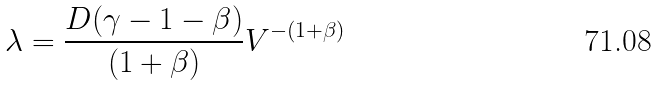Convert formula to latex. <formula><loc_0><loc_0><loc_500><loc_500>\lambda = \frac { D ( \gamma - 1 - \beta ) } { ( 1 + \beta ) } V ^ { - ( 1 + \beta ) }</formula> 